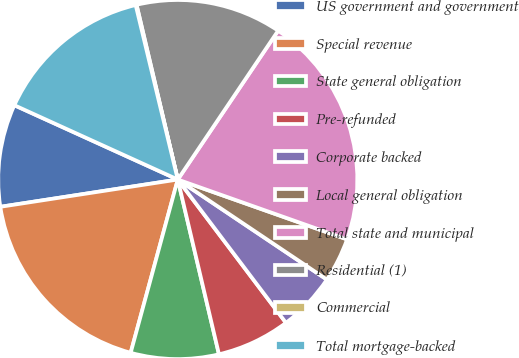<chart> <loc_0><loc_0><loc_500><loc_500><pie_chart><fcel>US government and government<fcel>Special revenue<fcel>State general obligation<fcel>Pre-refunded<fcel>Corporate backed<fcel>Local general obligation<fcel>Total state and municipal<fcel>Residential (1)<fcel>Commercial<fcel>Total mortgage-backed<nl><fcel>9.22%<fcel>18.35%<fcel>7.91%<fcel>6.61%<fcel>5.3%<fcel>4.0%<fcel>20.97%<fcel>13.13%<fcel>0.08%<fcel>14.44%<nl></chart> 